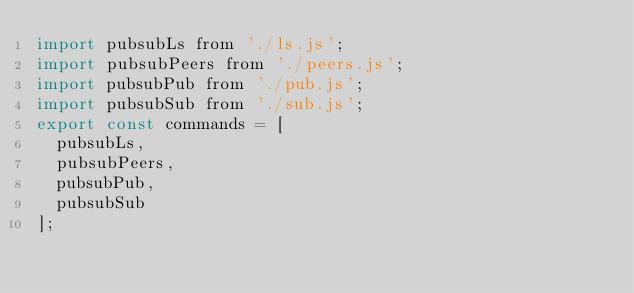<code> <loc_0><loc_0><loc_500><loc_500><_JavaScript_>import pubsubLs from './ls.js';
import pubsubPeers from './peers.js';
import pubsubPub from './pub.js';
import pubsubSub from './sub.js';
export const commands = [
  pubsubLs,
  pubsubPeers,
  pubsubPub,
  pubsubSub
];</code> 